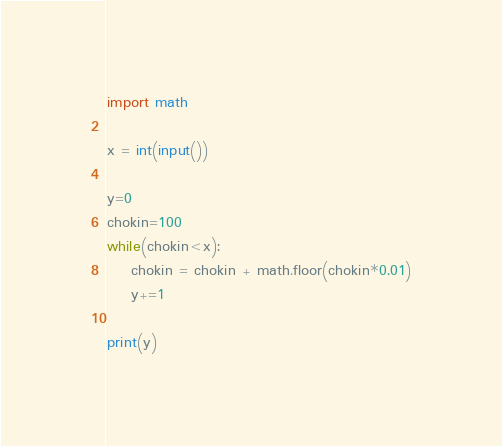Convert code to text. <code><loc_0><loc_0><loc_500><loc_500><_Python_>import math

x = int(input())

y=0
chokin=100
while(chokin<x):
    chokin = chokin + math.floor(chokin*0.01)
    y+=1

print(y)
</code> 